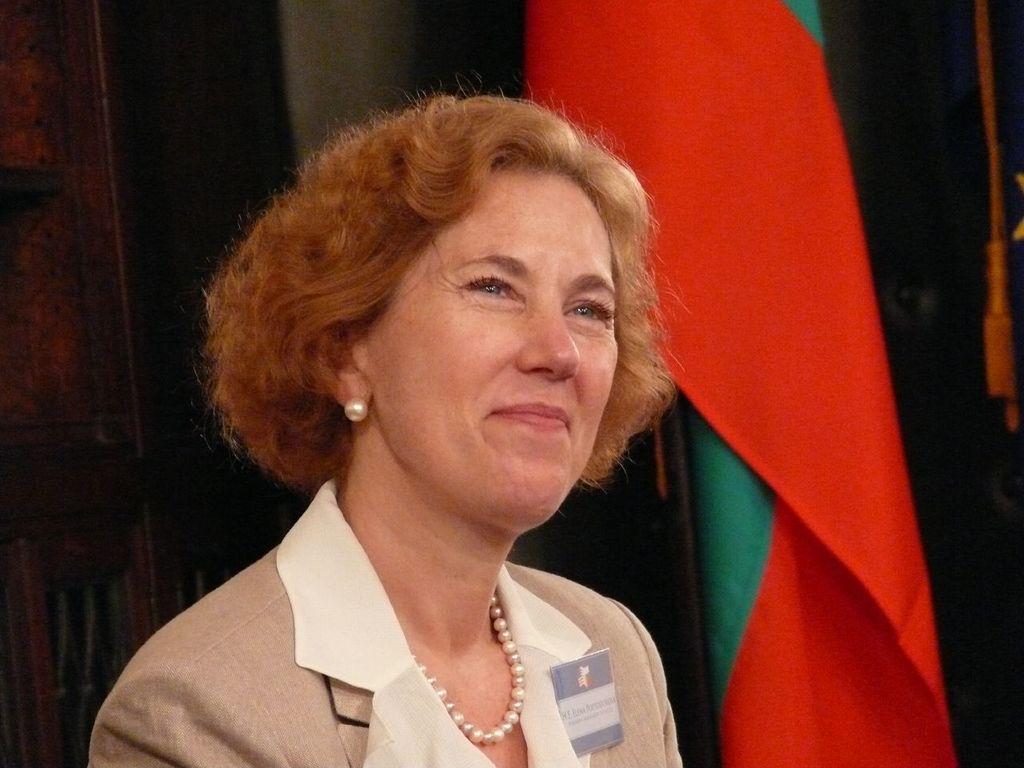How would you summarize this image in a sentence or two? This is a zoomed in picture. In the foreground there is a person wearing blazer and smiling. In the background there is a wall and we can see a flag and some other objects. 